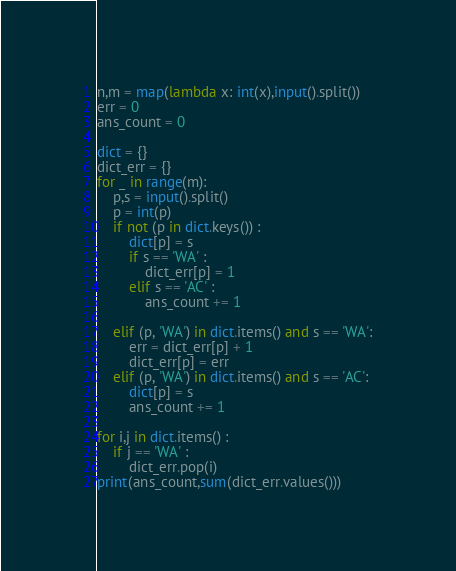Convert code to text. <code><loc_0><loc_0><loc_500><loc_500><_Python_>n,m = map(lambda x: int(x),input().split())
err = 0
ans_count = 0

dict = {}
dict_err = {}
for _ in range(m):
    p,s = input().split()
    p = int(p)
    if not (p in dict.keys()) :
        dict[p] = s
        if s == 'WA' :
            dict_err[p] = 1
        elif s == 'AC' :
            ans_count += 1

    elif (p, 'WA') in dict.items() and s == 'WA':
        err = dict_err[p] + 1
        dict_err[p] = err
    elif (p, 'WA') in dict.items() and s == 'AC':
        dict[p] = s
        ans_count += 1

for i,j in dict.items() :
    if j == 'WA' :
        dict_err.pop(i)
print(ans_count,sum(dict_err.values()))
</code> 